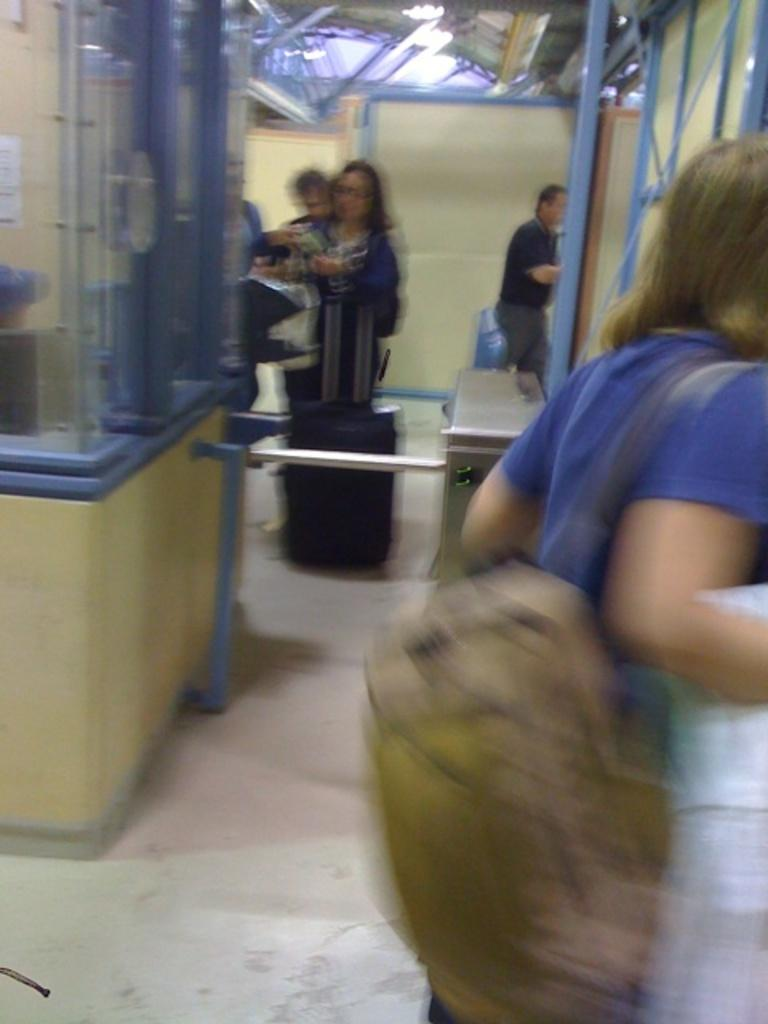What is the man in the image doing? The man is standing near a partition in the image. What can be seen in the background of the image? There are people standing near a table and a box in the background of the image. What structure is visible at the top of the image? There is a shed visible at the top of the image. What type of cloth is draped over the table in the image? There is no cloth draped over the table in the image. What type of drink is being served in the box in the image? There is no drink, such as eggnog, mentioned or visible in the image. 